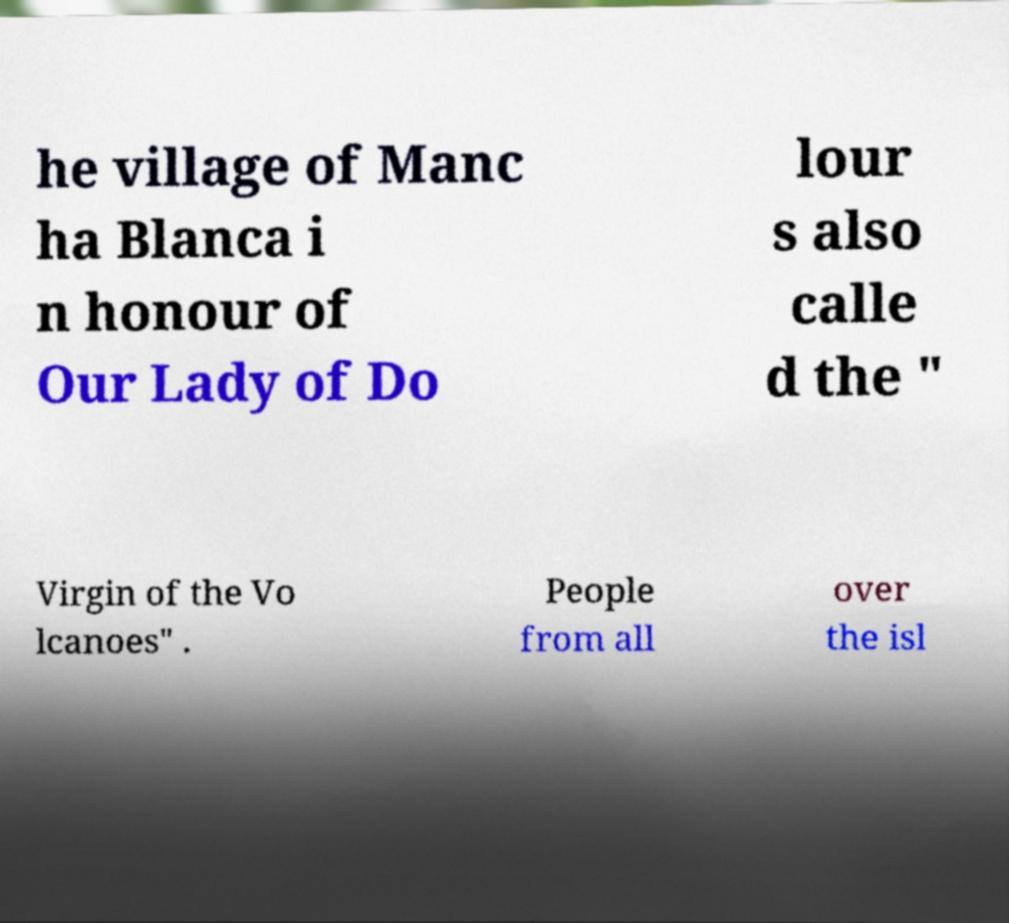Please read and relay the text visible in this image. What does it say? he village of Manc ha Blanca i n honour of Our Lady of Do lour s also calle d the " Virgin of the Vo lcanoes" . People from all over the isl 